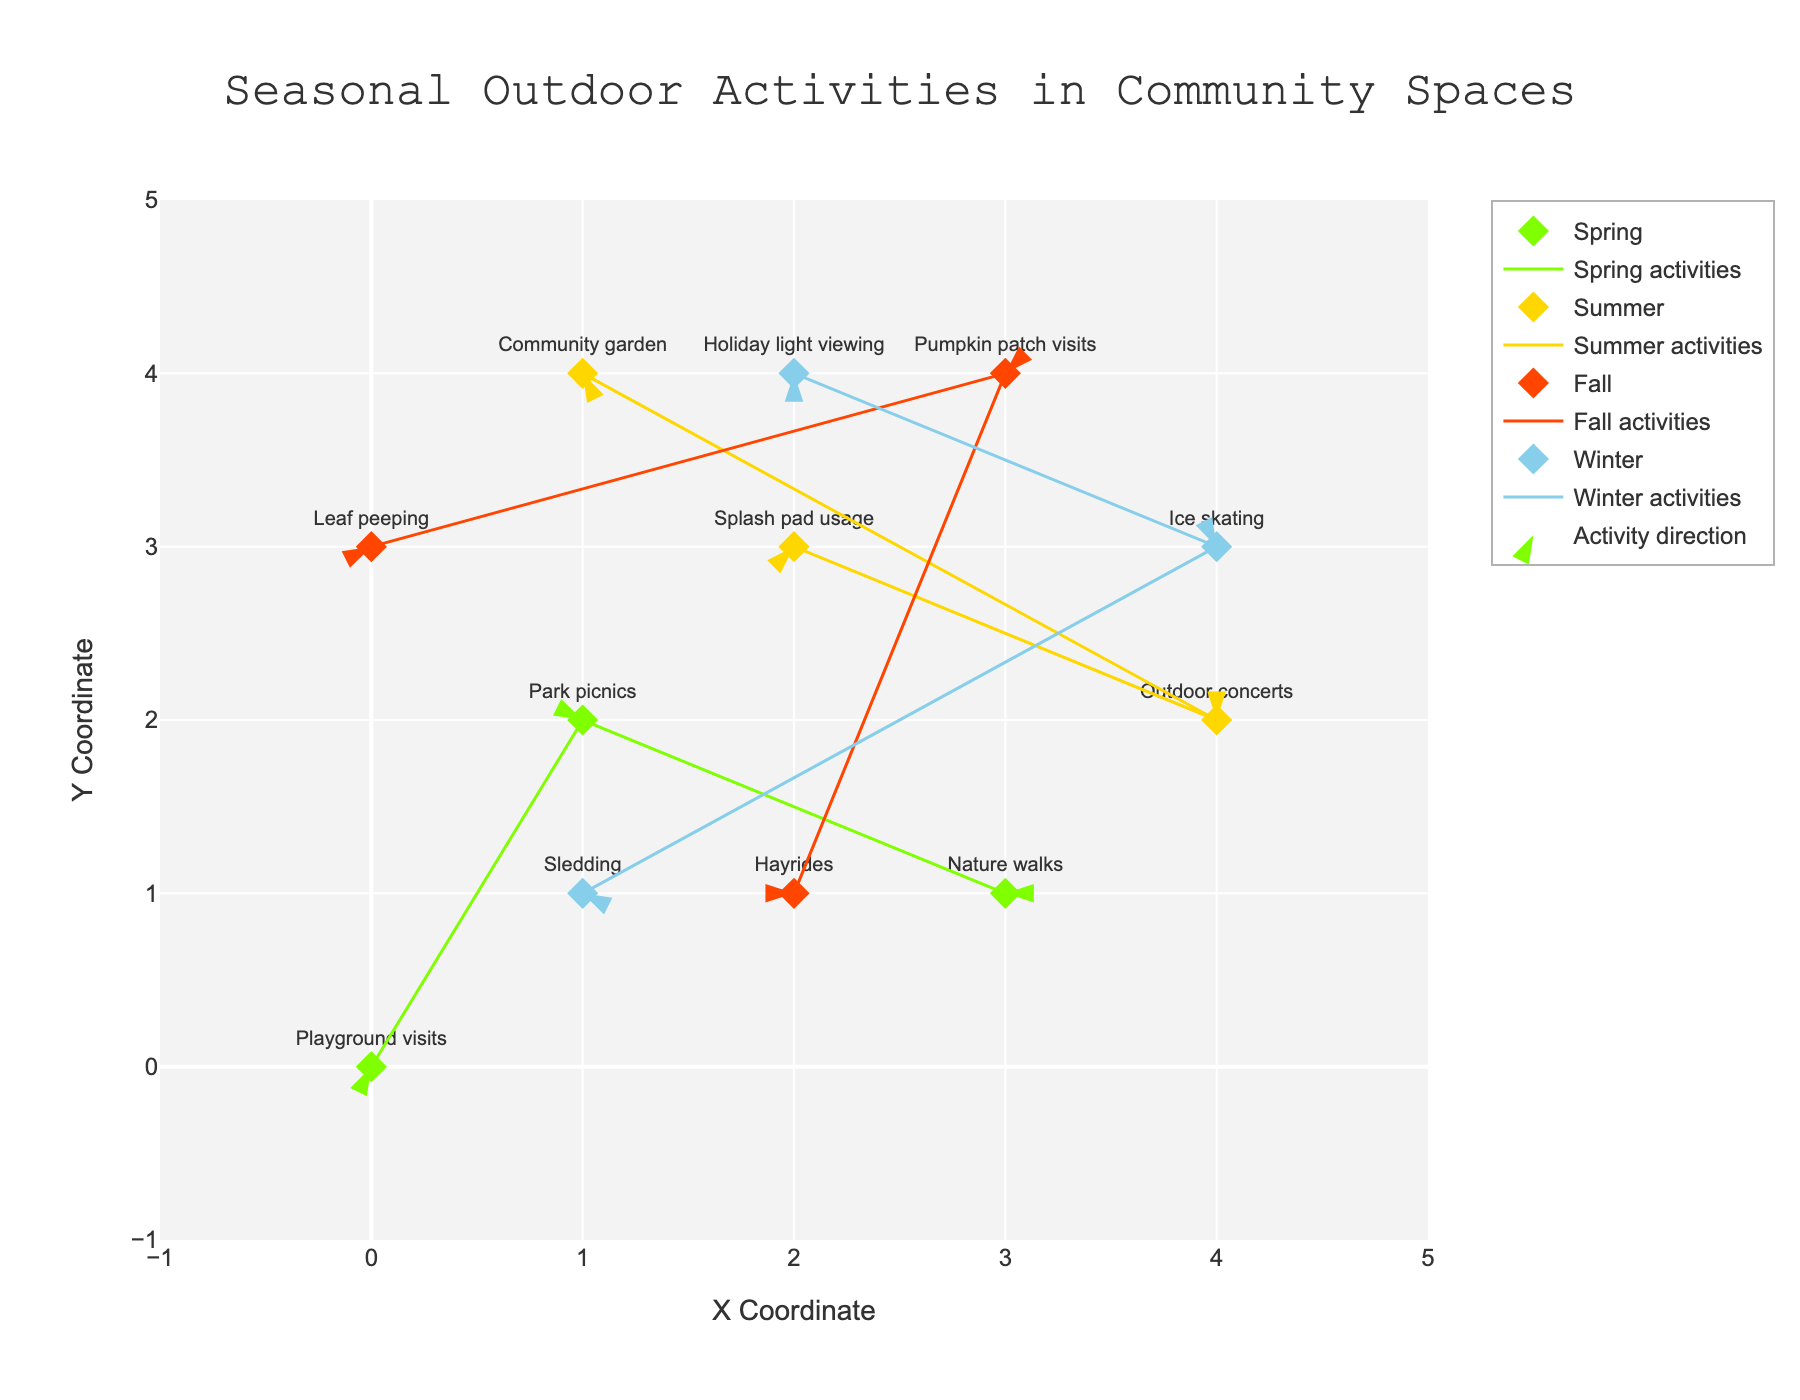What is the title of the plot? The title is positioned at the top center of the plot. It states "Seasonal Outdoor Activities in Community Spaces," indicating the central theme of the visualization.
Answer: Seasonal Outdoor Activities in Community Spaces Which season has the activity "Splash pad usage"? By examining the labels of the markers, the activity "Splash pad usage" occurs in Summer.
Answer: Summer How many Winter activities are shown in the plot? Look at the markers with text labels depicting Winter activities. There are "Sledding," "Ice skating," and "Holiday light viewing," totaling three activities.
Answer: Three What is the overall trend of outdoor concerts from its starting point and direction (u, v) value? The point for "Outdoor concerts" is positioned at (4, 2), and the arrow direction is denoted by (-2, 0). This means it moves two steps left (indicating a westward direction) without any vertical movement.
Answer: Two steps left Compare the number of activities in Summer and Fall. Which season has more? Count the markers for each season. Summer has three activities ("Splash pad usage," "Outdoor concerts," and "Community garden") and Fall also has three activities ("Leaf peeping," "Pumpkin patch visits," and "Hayrides"). The count is equal.
Answer: Equal What is the easternmost activity in the plot? The easternmost activity would be the one with the highest x-coordinate. "Ice skating" in Winter is at coordinate (4, 3), making it the farthest east.
Answer: Ice skating Which activity has the largest vertical component (v value) in any direction? Look for the activity with the highest absolute value of the vertical direction component (v). "Park picnics" in Spring has a v value of 2, indicating it moves up the most.
Answer: Park picnics How does the spatial distribution of Fall activities compare to that of Winter activities? Examining the markers and arrows for Fall, activities are more dispersed across varying x and y coordinates (0,3; 3,4; 2,1). Winter activities are similarly dispersed but also include higher x positions like (4,3; 2,4). The distributions are fairly broad for both.
Answer: Fairly broad for both Which season's activities appear most concentrated within a particular area in the plot? Activities should be assessed based on proximity to each other. Spring activities ("Playground visits," "Park picnics," and "Nature walks") mostly cluster around the center-left, suggesting concentration.
Answer: Spring 